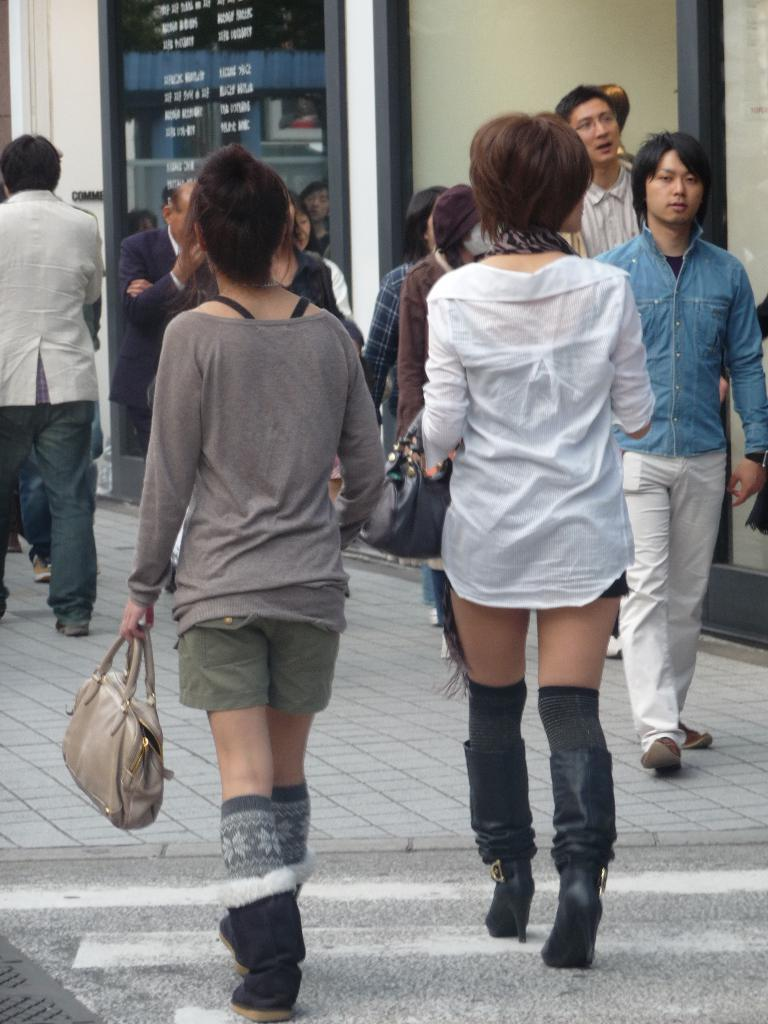What is present in the image that serves as a barrier or divider? There is a wall in the image. What activity are the people in the image engaged in? The people in the image are walking on a road. What type of pig can be seen writing a story in the image? There is no pig or writing activity present in the image. What kind of creature is depicted interacting with the wall in the image? There is no creature shown interacting with the wall in the image; only the wall and people walking on a road are present. 